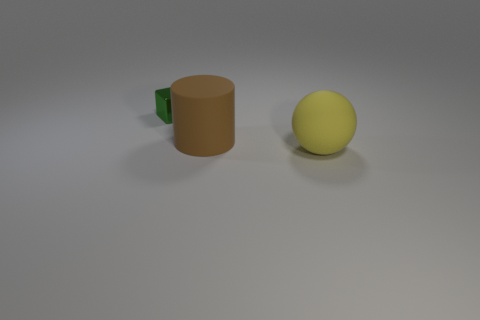Add 3 big matte things. How many objects exist? 6 Subtract all blocks. How many objects are left? 2 Add 1 yellow matte objects. How many yellow matte objects exist? 2 Subtract 0 green spheres. How many objects are left? 3 Subtract all big balls. Subtract all spheres. How many objects are left? 1 Add 3 small green shiny objects. How many small green shiny objects are left? 4 